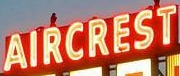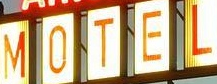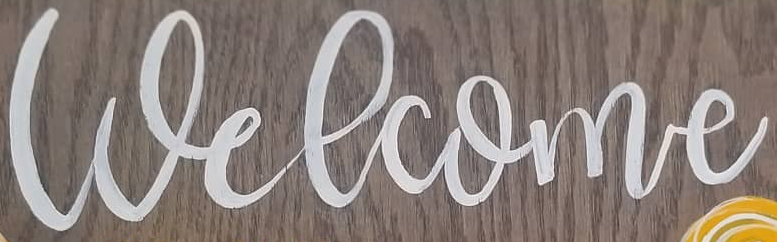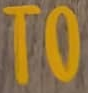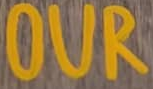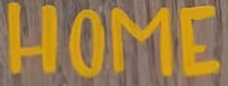What text is displayed in these images sequentially, separated by a semicolon? AIRCREST; MOTEL; Welcome; TO; OUR; HOME 